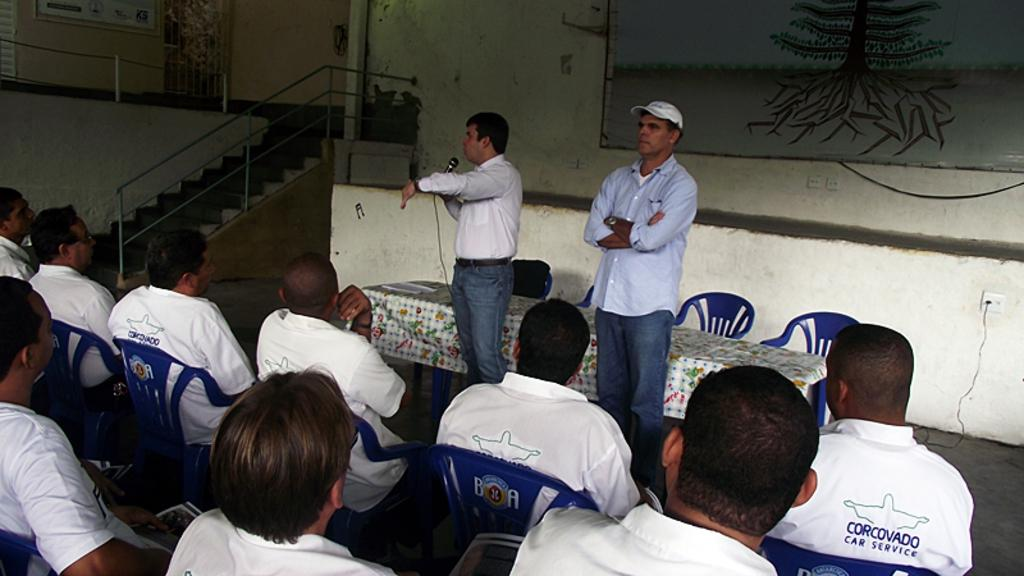<image>
Present a compact description of the photo's key features. People are gathered at a meeting and some of them have car service shirts on. 